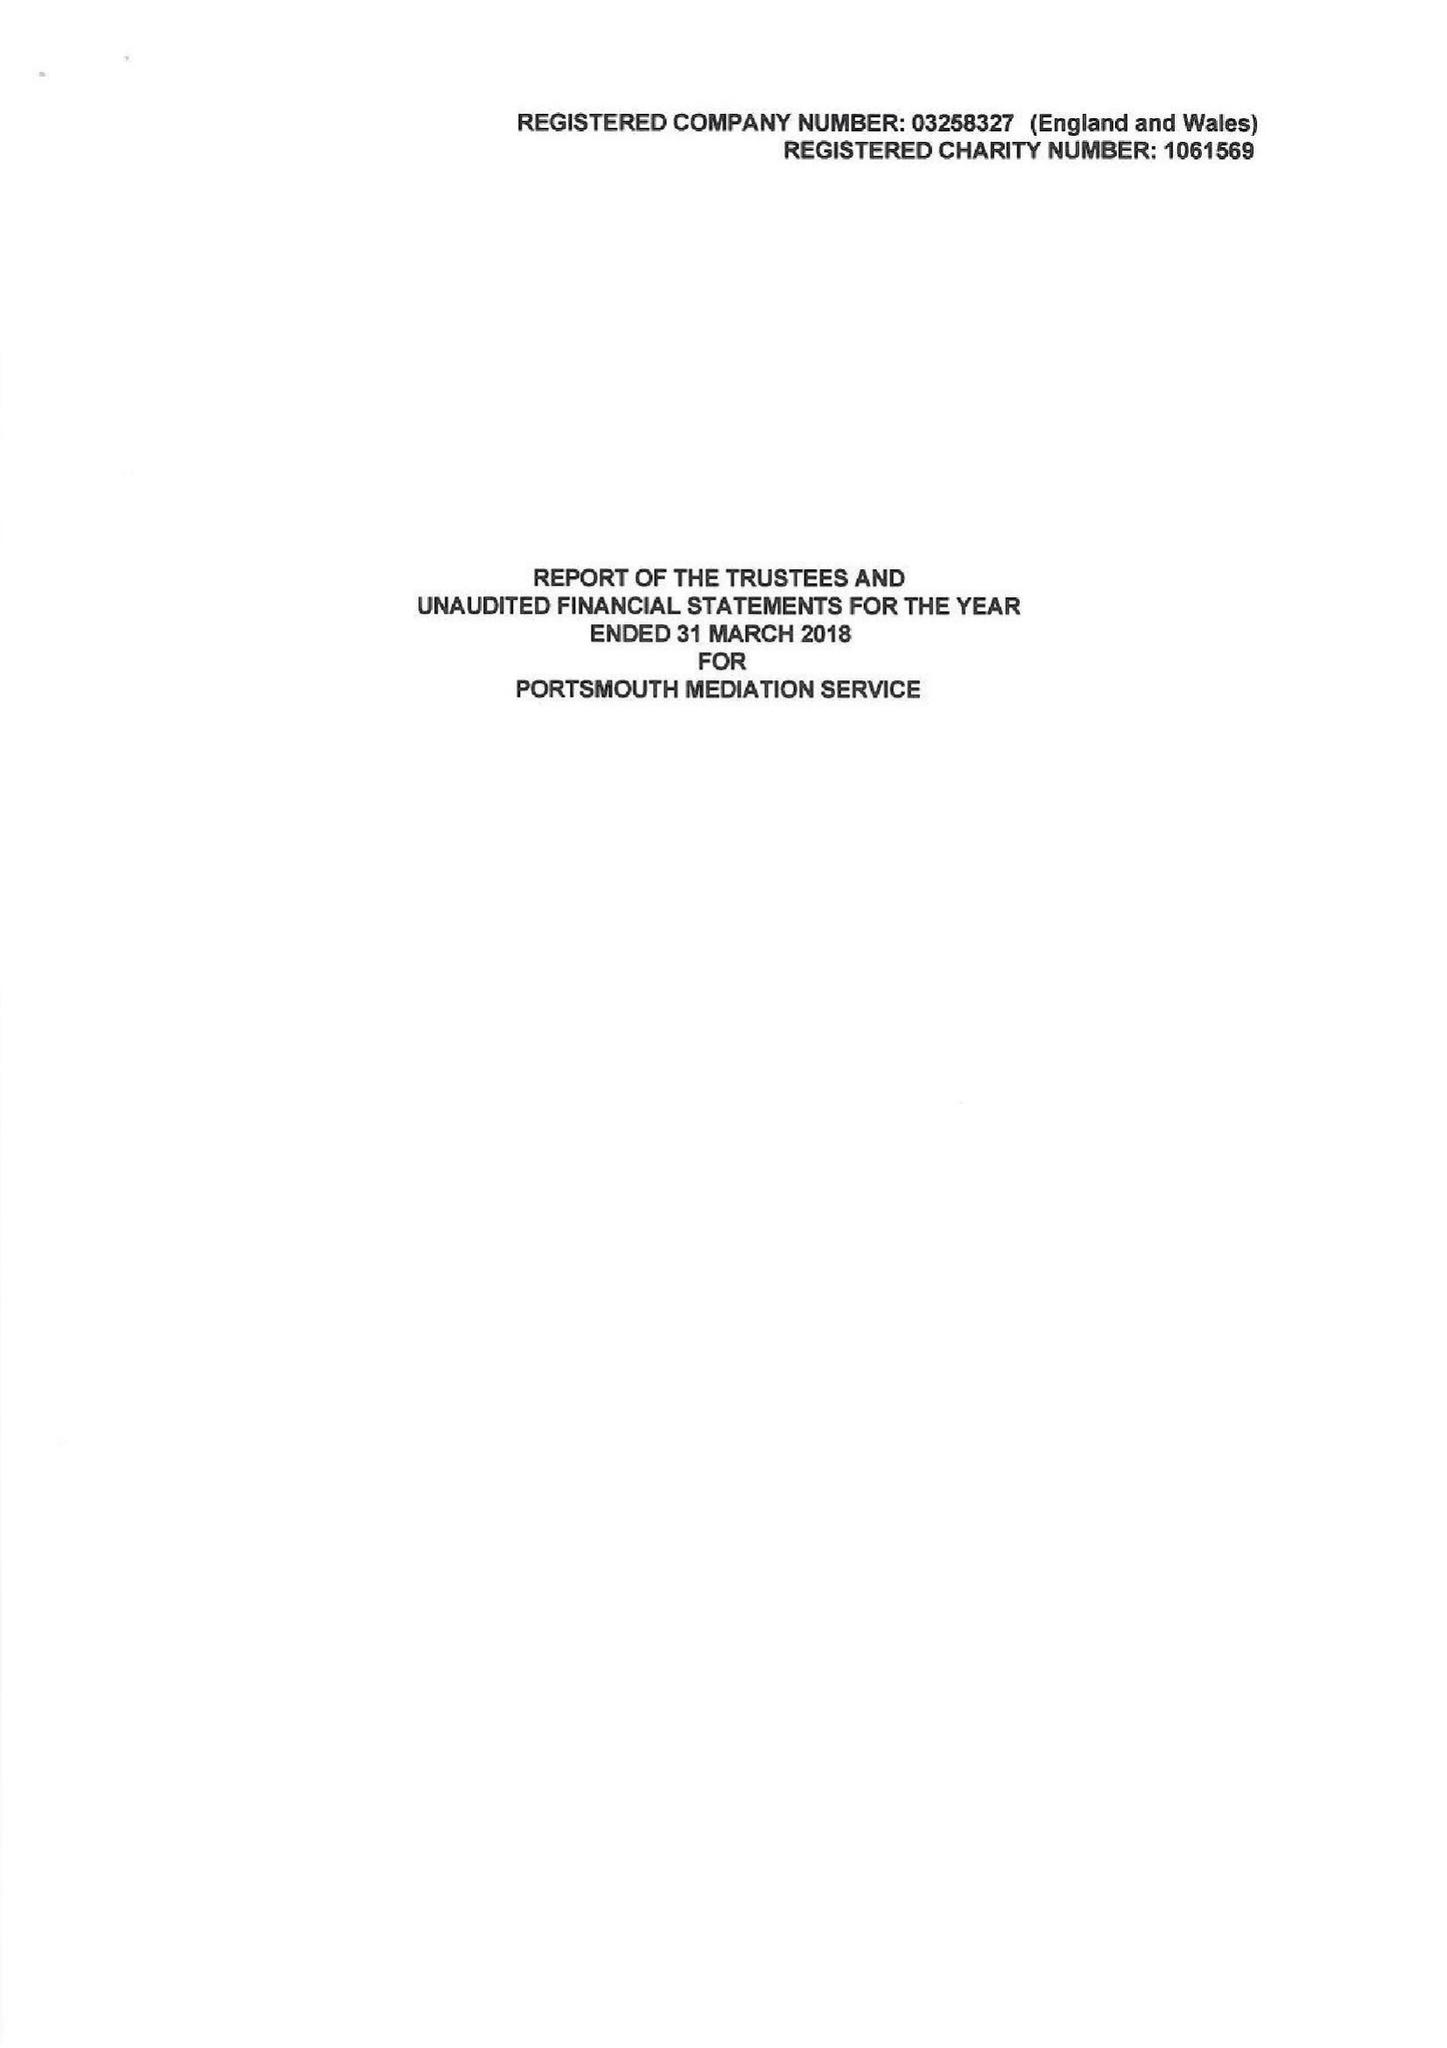What is the value for the address__street_line?
Answer the question using a single word or phrase. ARUNDEL STREET 